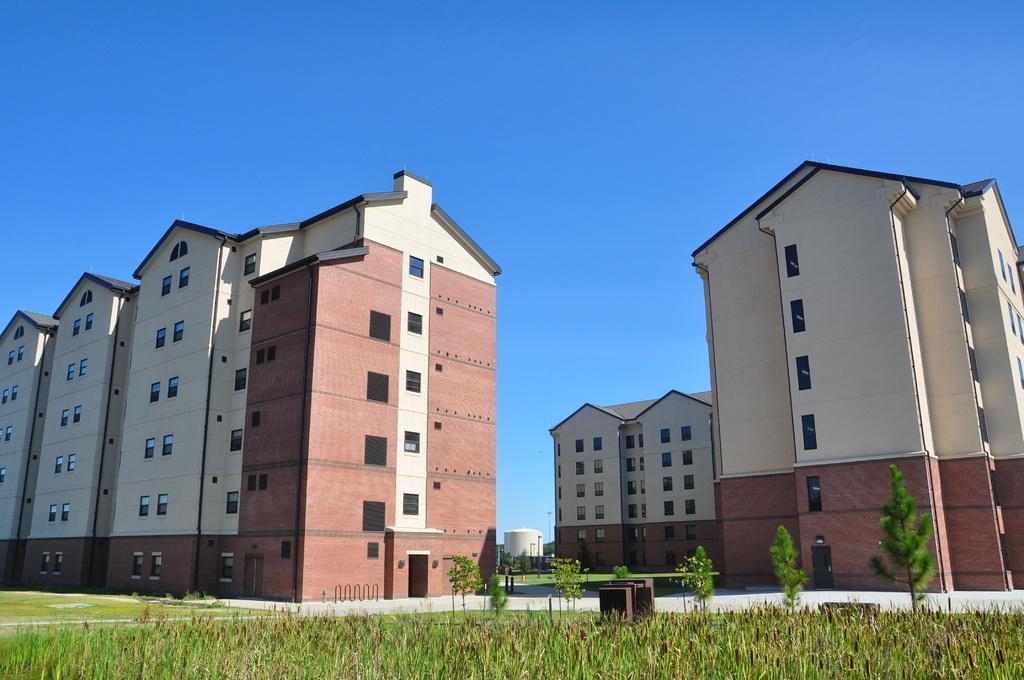Please provide a concise description of this image. In this image we can see buildings with windows. At the bottom there are plants and grass. In the background there is sky. 